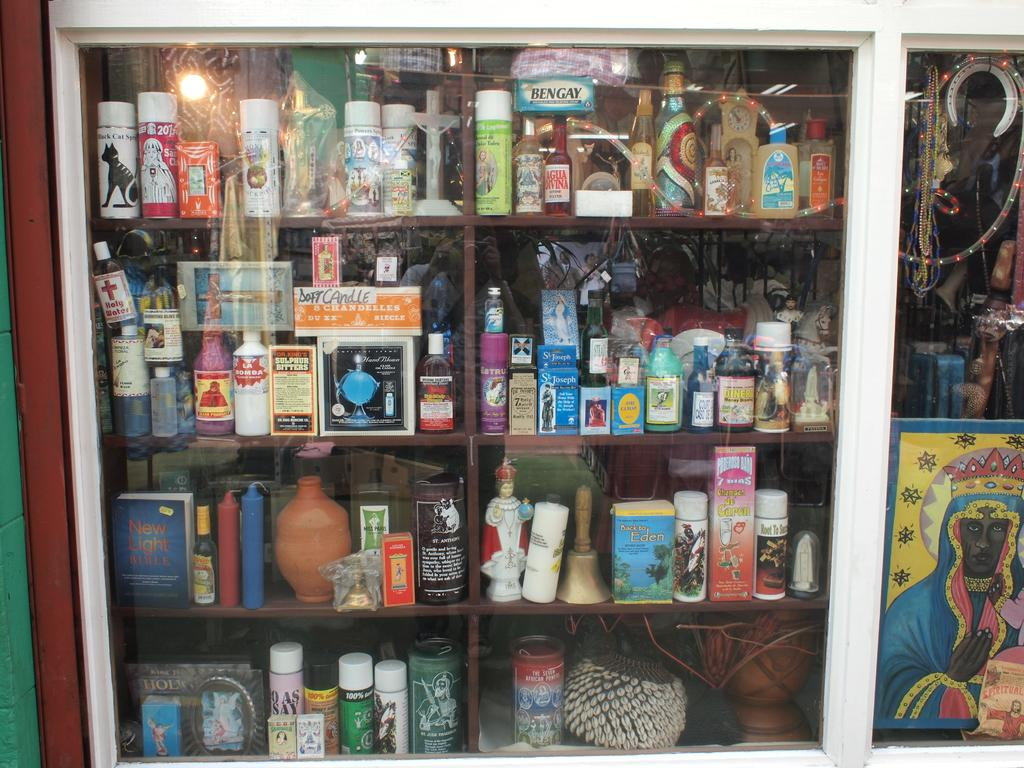<image>
Present a compact description of the photo's key features. A set of shelves behind a glass door with a box of Ben Gay near the top. 